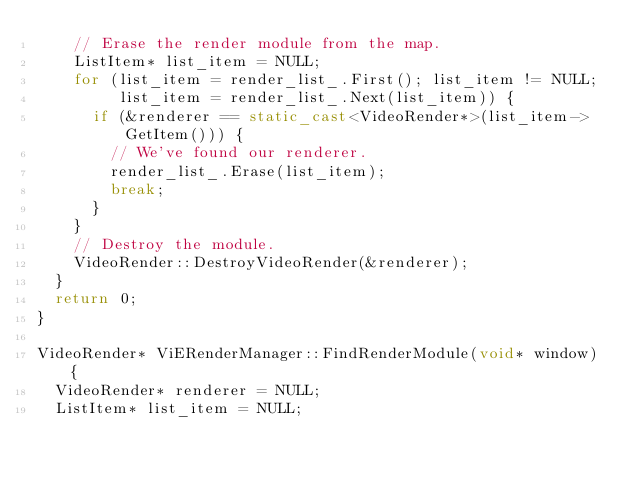<code> <loc_0><loc_0><loc_500><loc_500><_C++_>    // Erase the render module from the map.
    ListItem* list_item = NULL;
    for (list_item = render_list_.First(); list_item != NULL;
         list_item = render_list_.Next(list_item)) {
      if (&renderer == static_cast<VideoRender*>(list_item->GetItem())) {
        // We've found our renderer.
        render_list_.Erase(list_item);
        break;
      }
    }
    // Destroy the module.
    VideoRender::DestroyVideoRender(&renderer);
  }
  return 0;
}

VideoRender* ViERenderManager::FindRenderModule(void* window) {
  VideoRender* renderer = NULL;
  ListItem* list_item = NULL;</code> 